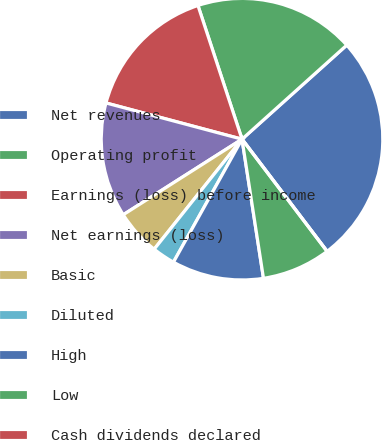Convert chart. <chart><loc_0><loc_0><loc_500><loc_500><pie_chart><fcel>Net revenues<fcel>Operating profit<fcel>Earnings (loss) before income<fcel>Net earnings (loss)<fcel>Basic<fcel>Diluted<fcel>High<fcel>Low<fcel>Cash dividends declared<nl><fcel>26.32%<fcel>18.42%<fcel>15.79%<fcel>13.16%<fcel>5.26%<fcel>2.63%<fcel>10.53%<fcel>7.89%<fcel>0.0%<nl></chart> 